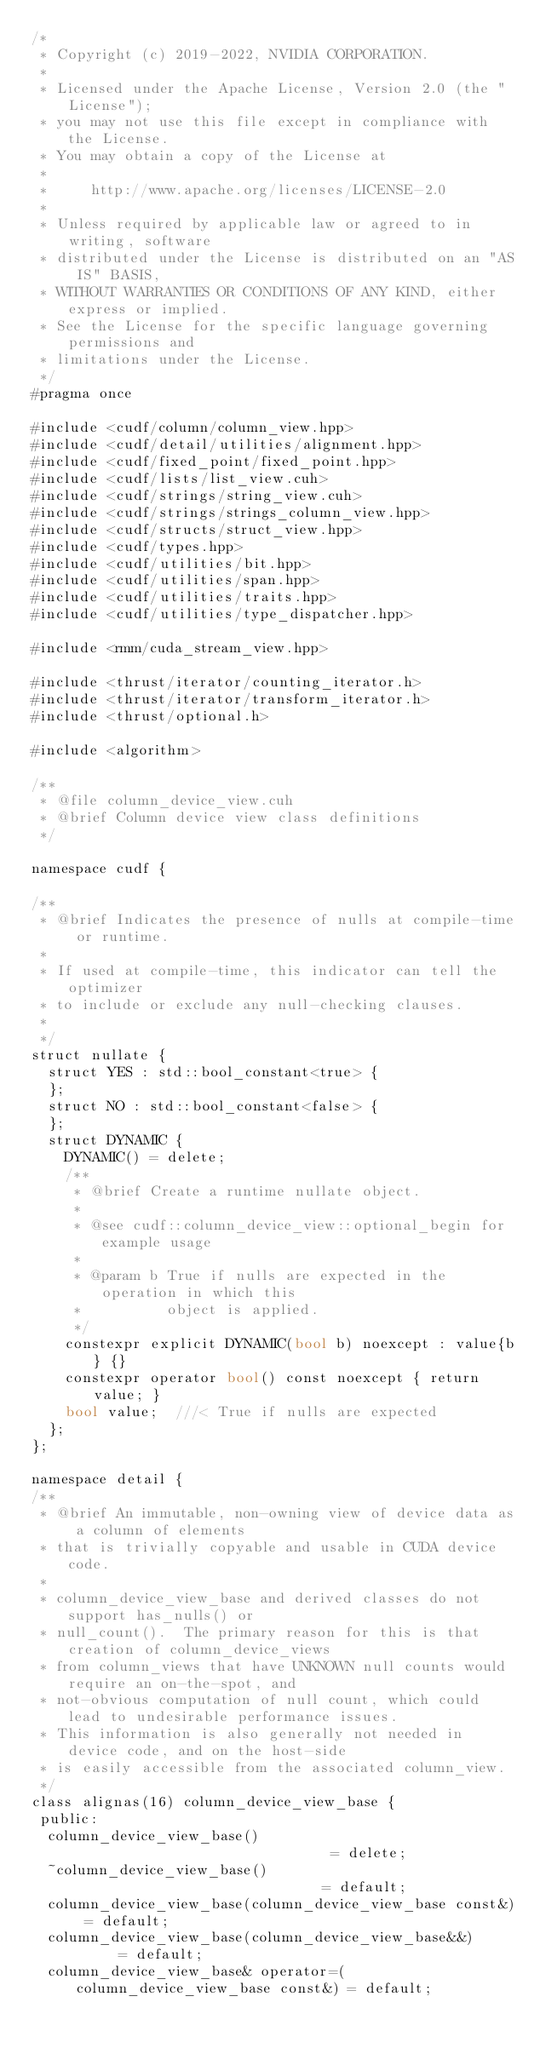Convert code to text. <code><loc_0><loc_0><loc_500><loc_500><_Cuda_>/*
 * Copyright (c) 2019-2022, NVIDIA CORPORATION.
 *
 * Licensed under the Apache License, Version 2.0 (the "License");
 * you may not use this file except in compliance with the License.
 * You may obtain a copy of the License at
 *
 *     http://www.apache.org/licenses/LICENSE-2.0
 *
 * Unless required by applicable law or agreed to in writing, software
 * distributed under the License is distributed on an "AS IS" BASIS,
 * WITHOUT WARRANTIES OR CONDITIONS OF ANY KIND, either express or implied.
 * See the License for the specific language governing permissions and
 * limitations under the License.
 */
#pragma once

#include <cudf/column/column_view.hpp>
#include <cudf/detail/utilities/alignment.hpp>
#include <cudf/fixed_point/fixed_point.hpp>
#include <cudf/lists/list_view.cuh>
#include <cudf/strings/string_view.cuh>
#include <cudf/strings/strings_column_view.hpp>
#include <cudf/structs/struct_view.hpp>
#include <cudf/types.hpp>
#include <cudf/utilities/bit.hpp>
#include <cudf/utilities/span.hpp>
#include <cudf/utilities/traits.hpp>
#include <cudf/utilities/type_dispatcher.hpp>

#include <rmm/cuda_stream_view.hpp>

#include <thrust/iterator/counting_iterator.h>
#include <thrust/iterator/transform_iterator.h>
#include <thrust/optional.h>

#include <algorithm>

/**
 * @file column_device_view.cuh
 * @brief Column device view class definitions
 */

namespace cudf {

/**
 * @brief Indicates the presence of nulls at compile-time or runtime.
 *
 * If used at compile-time, this indicator can tell the optimizer
 * to include or exclude any null-checking clauses.
 *
 */
struct nullate {
  struct YES : std::bool_constant<true> {
  };
  struct NO : std::bool_constant<false> {
  };
  struct DYNAMIC {
    DYNAMIC() = delete;
    /**
     * @brief Create a runtime nullate object.
     *
     * @see cudf::column_device_view::optional_begin for example usage
     *
     * @param b True if nulls are expected in the operation in which this
     *          object is applied.
     */
    constexpr explicit DYNAMIC(bool b) noexcept : value{b} {}
    constexpr operator bool() const noexcept { return value; }
    bool value;  ///< True if nulls are expected
  };
};

namespace detail {
/**
 * @brief An immutable, non-owning view of device data as a column of elements
 * that is trivially copyable and usable in CUDA device code.
 *
 * column_device_view_base and derived classes do not support has_nulls() or
 * null_count().  The primary reason for this is that creation of column_device_views
 * from column_views that have UNKNOWN null counts would require an on-the-spot, and
 * not-obvious computation of null count, which could lead to undesirable performance issues.
 * This information is also generally not needed in device code, and on the host-side
 * is easily accessible from the associated column_view.
 */
class alignas(16) column_device_view_base {
 public:
  column_device_view_base()                               = delete;
  ~column_device_view_base()                              = default;
  column_device_view_base(column_device_view_base const&) = default;
  column_device_view_base(column_device_view_base&&)      = default;
  column_device_view_base& operator=(column_device_view_base const&) = default;</code> 